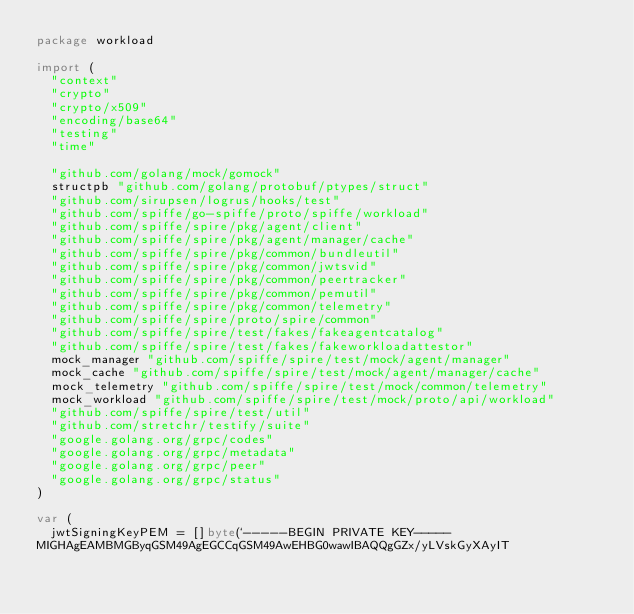<code> <loc_0><loc_0><loc_500><loc_500><_Go_>package workload

import (
	"context"
	"crypto"
	"crypto/x509"
	"encoding/base64"
	"testing"
	"time"

	"github.com/golang/mock/gomock"
	structpb "github.com/golang/protobuf/ptypes/struct"
	"github.com/sirupsen/logrus/hooks/test"
	"github.com/spiffe/go-spiffe/proto/spiffe/workload"
	"github.com/spiffe/spire/pkg/agent/client"
	"github.com/spiffe/spire/pkg/agent/manager/cache"
	"github.com/spiffe/spire/pkg/common/bundleutil"
	"github.com/spiffe/spire/pkg/common/jwtsvid"
	"github.com/spiffe/spire/pkg/common/peertracker"
	"github.com/spiffe/spire/pkg/common/pemutil"
	"github.com/spiffe/spire/pkg/common/telemetry"
	"github.com/spiffe/spire/proto/spire/common"
	"github.com/spiffe/spire/test/fakes/fakeagentcatalog"
	"github.com/spiffe/spire/test/fakes/fakeworkloadattestor"
	mock_manager "github.com/spiffe/spire/test/mock/agent/manager"
	mock_cache "github.com/spiffe/spire/test/mock/agent/manager/cache"
	mock_telemetry "github.com/spiffe/spire/test/mock/common/telemetry"
	mock_workload "github.com/spiffe/spire/test/mock/proto/api/workload"
	"github.com/spiffe/spire/test/util"
	"github.com/stretchr/testify/suite"
	"google.golang.org/grpc/codes"
	"google.golang.org/grpc/metadata"
	"google.golang.org/grpc/peer"
	"google.golang.org/grpc/status"
)

var (
	jwtSigningKeyPEM = []byte(`-----BEGIN PRIVATE KEY-----
MIGHAgEAMBMGByqGSM49AgEGCCqGSM49AwEHBG0wawIBAQQgGZx/yLVskGyXAyIT</code> 